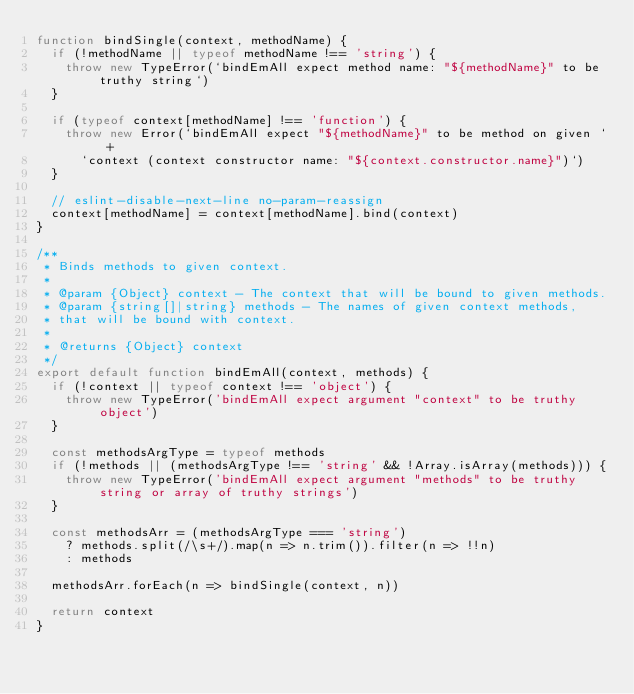<code> <loc_0><loc_0><loc_500><loc_500><_JavaScript_>function bindSingle(context, methodName) {
  if (!methodName || typeof methodName !== 'string') {
    throw new TypeError(`bindEmAll expect method name: "${methodName}" to be truthy string`)
  }

  if (typeof context[methodName] !== 'function') {
    throw new Error(`bindEmAll expect "${methodName}" to be method on given ` +
      `context (context constructor name: "${context.constructor.name}")`)
  }

  // eslint-disable-next-line no-param-reassign
  context[methodName] = context[methodName].bind(context)
}

/**
 * Binds methods to given context.
 *
 * @param {Object} context - The context that will be bound to given methods.
 * @param {string[]|string} methods - The names of given context methods,
 * that will be bound with context.
 *
 * @returns {Object} context
 */
export default function bindEmAll(context, methods) {
  if (!context || typeof context !== 'object') {
    throw new TypeError('bindEmAll expect argument "context" to be truthy object')
  }

  const methodsArgType = typeof methods
  if (!methods || (methodsArgType !== 'string' && !Array.isArray(methods))) {
    throw new TypeError('bindEmAll expect argument "methods" to be truthy string or array of truthy strings')
  }

  const methodsArr = (methodsArgType === 'string')
    ? methods.split(/\s+/).map(n => n.trim()).filter(n => !!n)
    : methods

  methodsArr.forEach(n => bindSingle(context, n))

  return context
}
</code> 